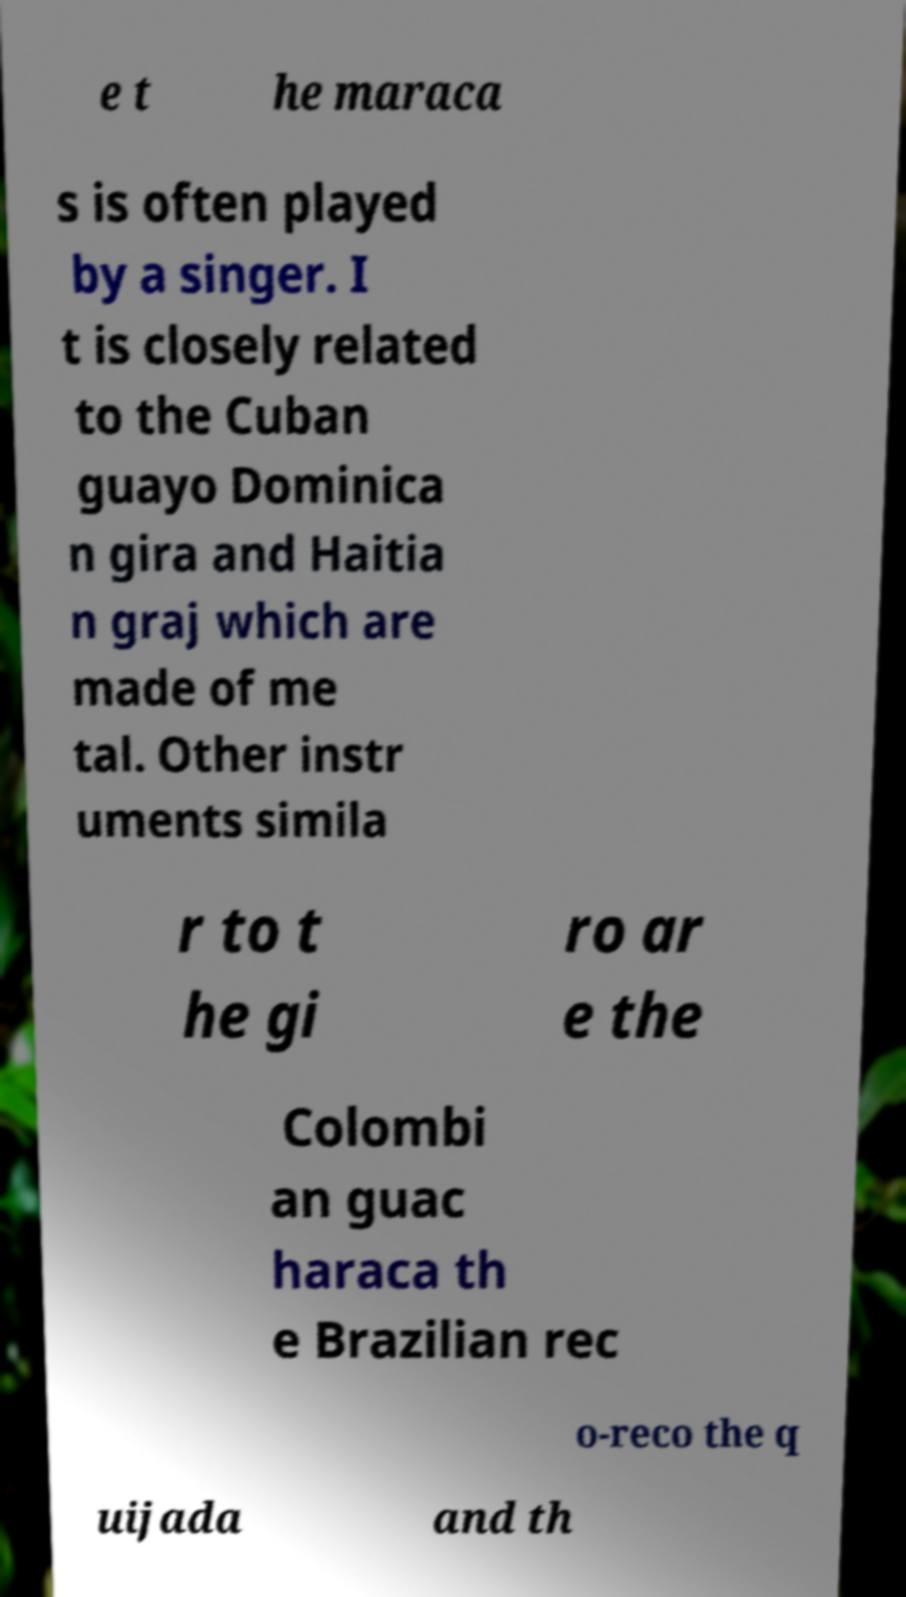Please read and relay the text visible in this image. What does it say? e t he maraca s is often played by a singer. I t is closely related to the Cuban guayo Dominica n gira and Haitia n graj which are made of me tal. Other instr uments simila r to t he gi ro ar e the Colombi an guac haraca th e Brazilian rec o-reco the q uijada and th 